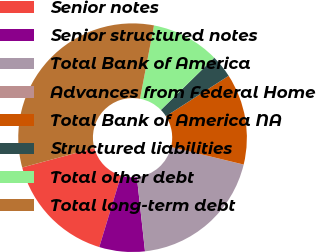Convert chart to OTSL. <chart><loc_0><loc_0><loc_500><loc_500><pie_chart><fcel>Senior notes<fcel>Senior structured notes<fcel>Total Bank of America<fcel>Advances from Federal Home<fcel>Total Bank of America NA<fcel>Structured liabilities<fcel>Total other debt<fcel>Total long-term debt<nl><fcel>16.1%<fcel>6.44%<fcel>19.48%<fcel>0.01%<fcel>12.88%<fcel>3.23%<fcel>9.66%<fcel>32.2%<nl></chart> 